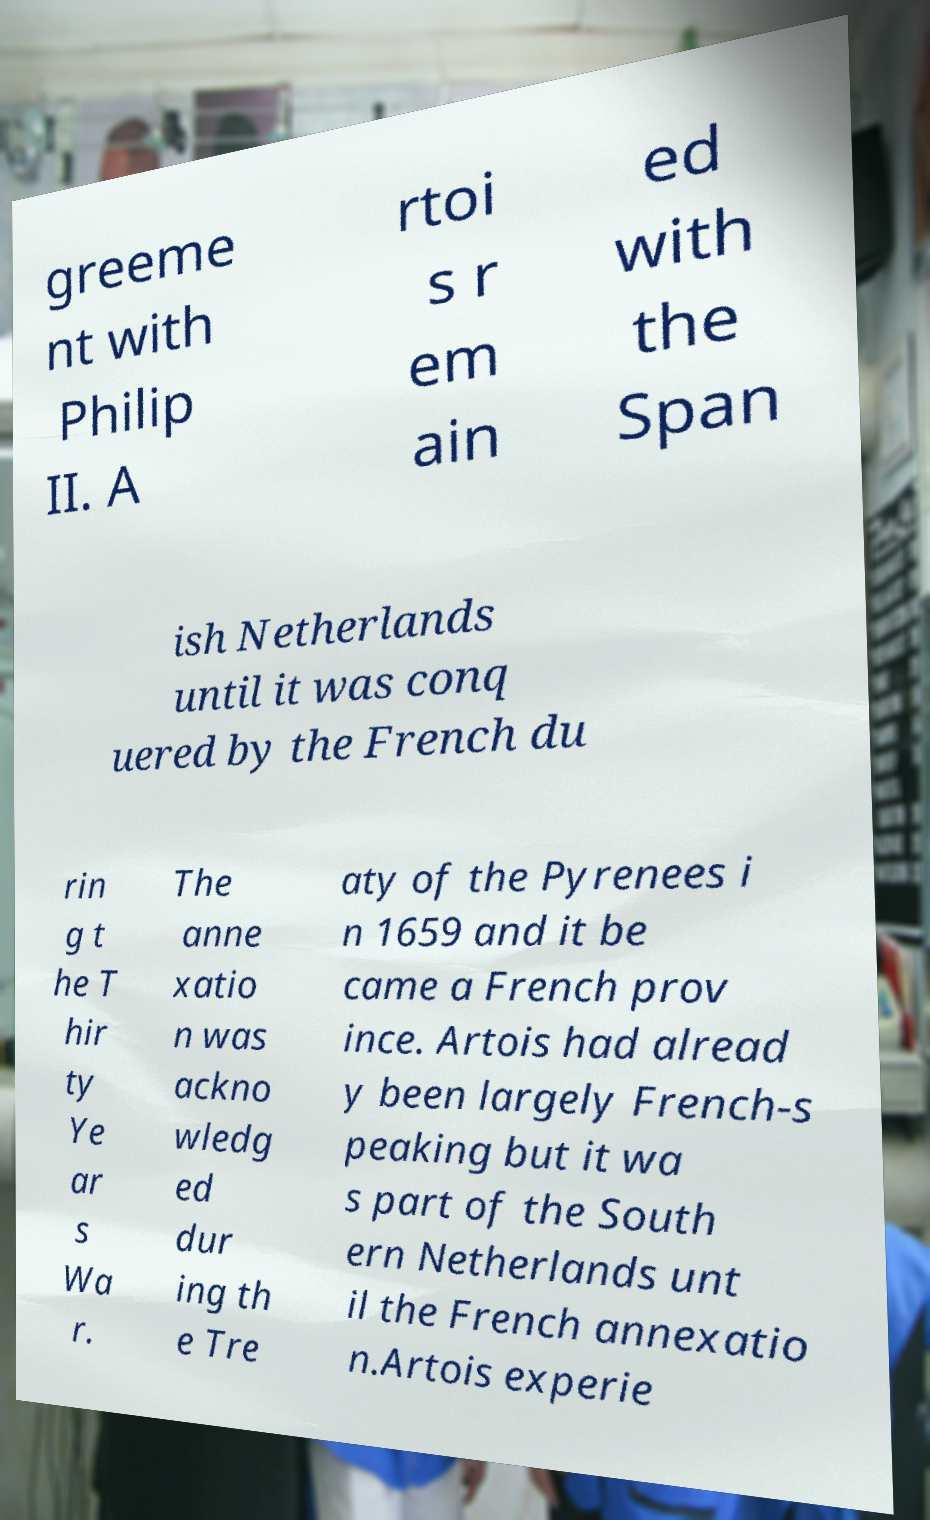There's text embedded in this image that I need extracted. Can you transcribe it verbatim? greeme nt with Philip II. A rtoi s r em ain ed with the Span ish Netherlands until it was conq uered by the French du rin g t he T hir ty Ye ar s Wa r. The anne xatio n was ackno wledg ed dur ing th e Tre aty of the Pyrenees i n 1659 and it be came a French prov ince. Artois had alread y been largely French-s peaking but it wa s part of the South ern Netherlands unt il the French annexatio n.Artois experie 